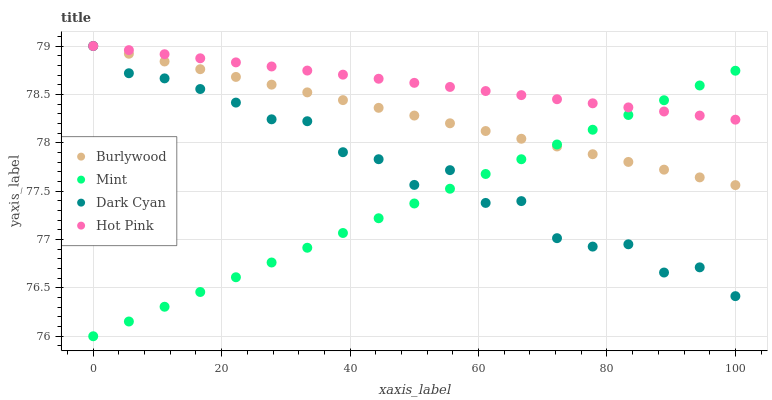Does Mint have the minimum area under the curve?
Answer yes or no. Yes. Does Hot Pink have the maximum area under the curve?
Answer yes or no. Yes. Does Dark Cyan have the minimum area under the curve?
Answer yes or no. No. Does Dark Cyan have the maximum area under the curve?
Answer yes or no. No. Is Burlywood the smoothest?
Answer yes or no. Yes. Is Dark Cyan the roughest?
Answer yes or no. Yes. Is Hot Pink the smoothest?
Answer yes or no. No. Is Hot Pink the roughest?
Answer yes or no. No. Does Mint have the lowest value?
Answer yes or no. Yes. Does Dark Cyan have the lowest value?
Answer yes or no. No. Does Hot Pink have the highest value?
Answer yes or no. Yes. Does Mint have the highest value?
Answer yes or no. No. Does Dark Cyan intersect Hot Pink?
Answer yes or no. Yes. Is Dark Cyan less than Hot Pink?
Answer yes or no. No. Is Dark Cyan greater than Hot Pink?
Answer yes or no. No. 